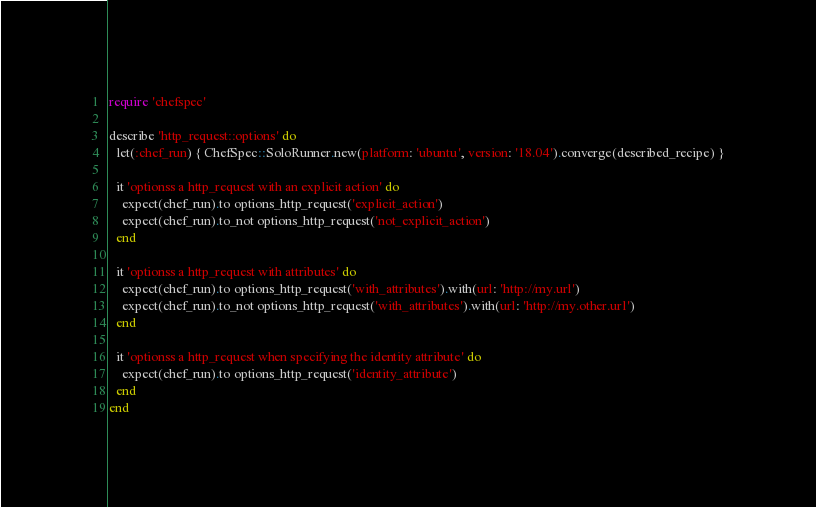<code> <loc_0><loc_0><loc_500><loc_500><_Ruby_>require 'chefspec'

describe 'http_request::options' do
  let(:chef_run) { ChefSpec::SoloRunner.new(platform: 'ubuntu', version: '18.04').converge(described_recipe) }

  it 'optionss a http_request with an explicit action' do
    expect(chef_run).to options_http_request('explicit_action')
    expect(chef_run).to_not options_http_request('not_explicit_action')
  end

  it 'optionss a http_request with attributes' do
    expect(chef_run).to options_http_request('with_attributes').with(url: 'http://my.url')
    expect(chef_run).to_not options_http_request('with_attributes').with(url: 'http://my.other.url')
  end

  it 'optionss a http_request when specifying the identity attribute' do
    expect(chef_run).to options_http_request('identity_attribute')
  end
end
</code> 